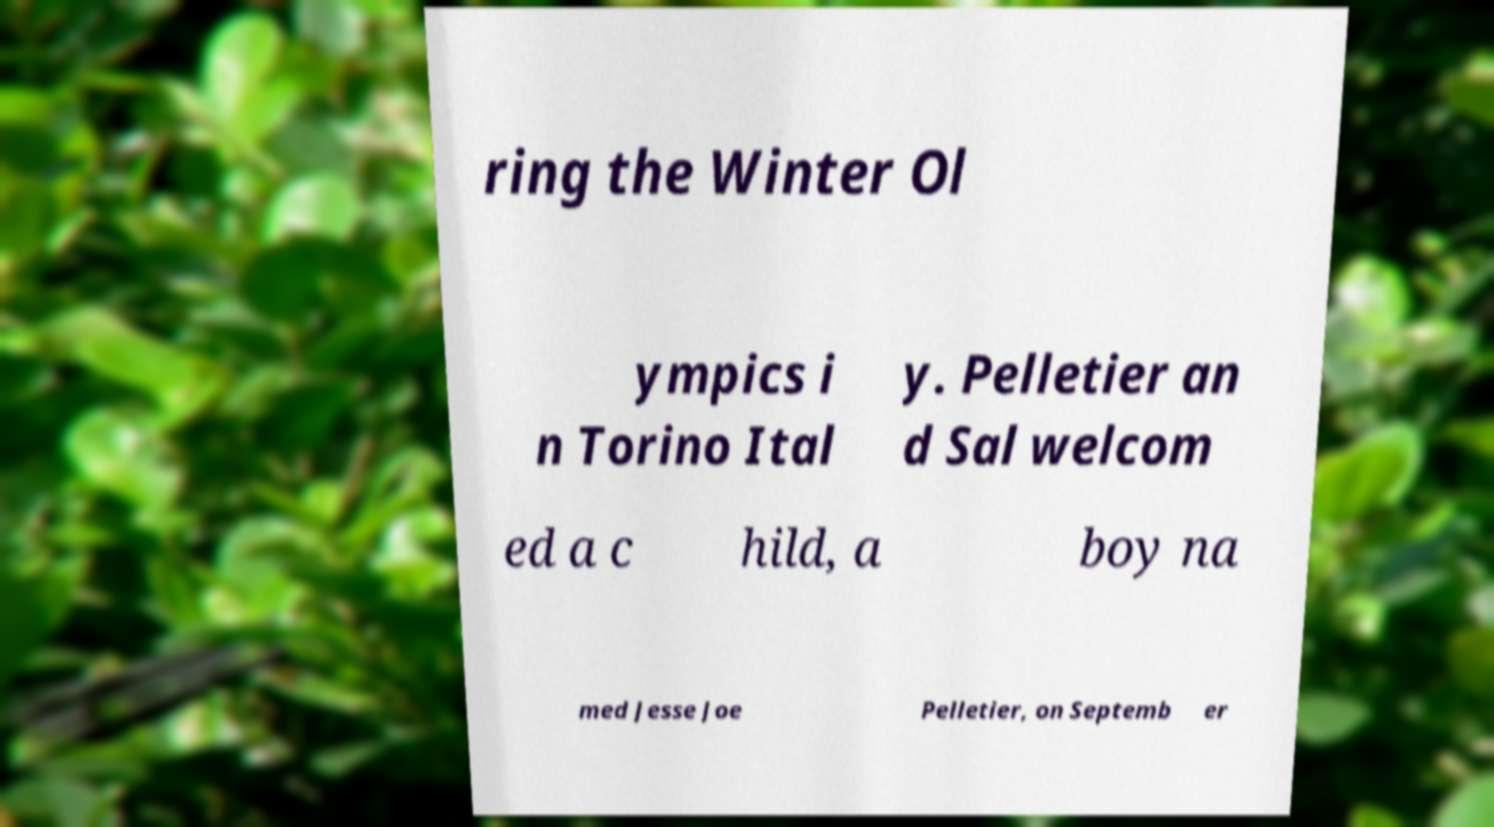Could you assist in decoding the text presented in this image and type it out clearly? ring the Winter Ol ympics i n Torino Ital y. Pelletier an d Sal welcom ed a c hild, a boy na med Jesse Joe Pelletier, on Septemb er 